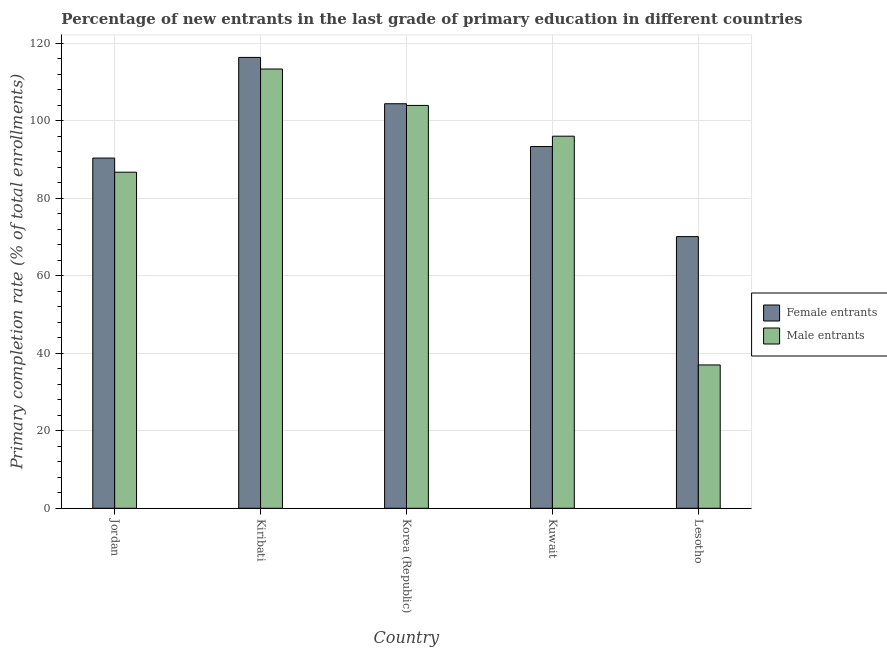How many different coloured bars are there?
Your answer should be compact. 2. How many groups of bars are there?
Provide a succinct answer. 5. Are the number of bars on each tick of the X-axis equal?
Give a very brief answer. Yes. What is the label of the 3rd group of bars from the left?
Your response must be concise. Korea (Republic). What is the primary completion rate of female entrants in Lesotho?
Your answer should be very brief. 70.12. Across all countries, what is the maximum primary completion rate of male entrants?
Give a very brief answer. 113.37. Across all countries, what is the minimum primary completion rate of female entrants?
Provide a short and direct response. 70.12. In which country was the primary completion rate of male entrants maximum?
Your answer should be compact. Kiribati. In which country was the primary completion rate of male entrants minimum?
Your answer should be compact. Lesotho. What is the total primary completion rate of male entrants in the graph?
Offer a very short reply. 437.12. What is the difference between the primary completion rate of female entrants in Kiribati and that in Korea (Republic)?
Ensure brevity in your answer.  11.96. What is the difference between the primary completion rate of female entrants in Kiribati and the primary completion rate of male entrants in Kuwait?
Keep it short and to the point. 20.33. What is the average primary completion rate of male entrants per country?
Offer a very short reply. 87.42. What is the difference between the primary completion rate of female entrants and primary completion rate of male entrants in Lesotho?
Offer a very short reply. 33.13. In how many countries, is the primary completion rate of male entrants greater than 96 %?
Give a very brief answer. 3. What is the ratio of the primary completion rate of male entrants in Jordan to that in Kuwait?
Provide a succinct answer. 0.9. Is the primary completion rate of male entrants in Kuwait less than that in Lesotho?
Your answer should be very brief. No. What is the difference between the highest and the second highest primary completion rate of female entrants?
Provide a short and direct response. 11.96. What is the difference between the highest and the lowest primary completion rate of female entrants?
Your answer should be very brief. 46.25. In how many countries, is the primary completion rate of female entrants greater than the average primary completion rate of female entrants taken over all countries?
Offer a terse response. 2. What does the 2nd bar from the left in Lesotho represents?
Your answer should be compact. Male entrants. What does the 1st bar from the right in Jordan represents?
Provide a short and direct response. Male entrants. Are all the bars in the graph horizontal?
Your answer should be very brief. No. What is the difference between two consecutive major ticks on the Y-axis?
Keep it short and to the point. 20. Are the values on the major ticks of Y-axis written in scientific E-notation?
Your response must be concise. No. Does the graph contain any zero values?
Offer a very short reply. No. How many legend labels are there?
Your answer should be very brief. 2. How are the legend labels stacked?
Provide a succinct answer. Vertical. What is the title of the graph?
Ensure brevity in your answer.  Percentage of new entrants in the last grade of primary education in different countries. Does "Electricity and heat production" appear as one of the legend labels in the graph?
Give a very brief answer. No. What is the label or title of the Y-axis?
Offer a terse response. Primary completion rate (% of total enrollments). What is the Primary completion rate (% of total enrollments) of Female entrants in Jordan?
Offer a very short reply. 90.39. What is the Primary completion rate (% of total enrollments) in Male entrants in Jordan?
Your answer should be very brief. 86.74. What is the Primary completion rate (% of total enrollments) in Female entrants in Kiribati?
Provide a succinct answer. 116.37. What is the Primary completion rate (% of total enrollments) of Male entrants in Kiribati?
Offer a very short reply. 113.37. What is the Primary completion rate (% of total enrollments) in Female entrants in Korea (Republic)?
Your answer should be compact. 104.41. What is the Primary completion rate (% of total enrollments) in Male entrants in Korea (Republic)?
Your answer should be compact. 103.97. What is the Primary completion rate (% of total enrollments) in Female entrants in Kuwait?
Your response must be concise. 93.36. What is the Primary completion rate (% of total enrollments) in Male entrants in Kuwait?
Offer a terse response. 96.04. What is the Primary completion rate (% of total enrollments) of Female entrants in Lesotho?
Provide a succinct answer. 70.12. What is the Primary completion rate (% of total enrollments) in Male entrants in Lesotho?
Make the answer very short. 36.99. Across all countries, what is the maximum Primary completion rate (% of total enrollments) of Female entrants?
Your response must be concise. 116.37. Across all countries, what is the maximum Primary completion rate (% of total enrollments) of Male entrants?
Your answer should be very brief. 113.37. Across all countries, what is the minimum Primary completion rate (% of total enrollments) of Female entrants?
Give a very brief answer. 70.12. Across all countries, what is the minimum Primary completion rate (% of total enrollments) of Male entrants?
Ensure brevity in your answer.  36.99. What is the total Primary completion rate (% of total enrollments) in Female entrants in the graph?
Offer a very short reply. 474.65. What is the total Primary completion rate (% of total enrollments) of Male entrants in the graph?
Make the answer very short. 437.12. What is the difference between the Primary completion rate (% of total enrollments) of Female entrants in Jordan and that in Kiribati?
Give a very brief answer. -25.98. What is the difference between the Primary completion rate (% of total enrollments) of Male entrants in Jordan and that in Kiribati?
Offer a very short reply. -26.63. What is the difference between the Primary completion rate (% of total enrollments) in Female entrants in Jordan and that in Korea (Republic)?
Make the answer very short. -14.02. What is the difference between the Primary completion rate (% of total enrollments) in Male entrants in Jordan and that in Korea (Republic)?
Provide a short and direct response. -17.23. What is the difference between the Primary completion rate (% of total enrollments) in Female entrants in Jordan and that in Kuwait?
Offer a very short reply. -2.97. What is the difference between the Primary completion rate (% of total enrollments) of Male entrants in Jordan and that in Kuwait?
Ensure brevity in your answer.  -9.29. What is the difference between the Primary completion rate (% of total enrollments) in Female entrants in Jordan and that in Lesotho?
Make the answer very short. 20.27. What is the difference between the Primary completion rate (% of total enrollments) of Male entrants in Jordan and that in Lesotho?
Provide a succinct answer. 49.75. What is the difference between the Primary completion rate (% of total enrollments) in Female entrants in Kiribati and that in Korea (Republic)?
Give a very brief answer. 11.96. What is the difference between the Primary completion rate (% of total enrollments) of Male entrants in Kiribati and that in Korea (Republic)?
Offer a terse response. 9.4. What is the difference between the Primary completion rate (% of total enrollments) of Female entrants in Kiribati and that in Kuwait?
Provide a short and direct response. 23. What is the difference between the Primary completion rate (% of total enrollments) of Male entrants in Kiribati and that in Kuwait?
Your answer should be very brief. 17.34. What is the difference between the Primary completion rate (% of total enrollments) of Female entrants in Kiribati and that in Lesotho?
Provide a short and direct response. 46.25. What is the difference between the Primary completion rate (% of total enrollments) in Male entrants in Kiribati and that in Lesotho?
Give a very brief answer. 76.38. What is the difference between the Primary completion rate (% of total enrollments) of Female entrants in Korea (Republic) and that in Kuwait?
Give a very brief answer. 11.05. What is the difference between the Primary completion rate (% of total enrollments) in Male entrants in Korea (Republic) and that in Kuwait?
Ensure brevity in your answer.  7.94. What is the difference between the Primary completion rate (% of total enrollments) of Female entrants in Korea (Republic) and that in Lesotho?
Make the answer very short. 34.29. What is the difference between the Primary completion rate (% of total enrollments) in Male entrants in Korea (Republic) and that in Lesotho?
Ensure brevity in your answer.  66.98. What is the difference between the Primary completion rate (% of total enrollments) in Female entrants in Kuwait and that in Lesotho?
Your response must be concise. 23.25. What is the difference between the Primary completion rate (% of total enrollments) of Male entrants in Kuwait and that in Lesotho?
Make the answer very short. 59.05. What is the difference between the Primary completion rate (% of total enrollments) in Female entrants in Jordan and the Primary completion rate (% of total enrollments) in Male entrants in Kiribati?
Make the answer very short. -22.98. What is the difference between the Primary completion rate (% of total enrollments) of Female entrants in Jordan and the Primary completion rate (% of total enrollments) of Male entrants in Korea (Republic)?
Provide a succinct answer. -13.58. What is the difference between the Primary completion rate (% of total enrollments) of Female entrants in Jordan and the Primary completion rate (% of total enrollments) of Male entrants in Kuwait?
Provide a short and direct response. -5.65. What is the difference between the Primary completion rate (% of total enrollments) of Female entrants in Jordan and the Primary completion rate (% of total enrollments) of Male entrants in Lesotho?
Your answer should be compact. 53.4. What is the difference between the Primary completion rate (% of total enrollments) of Female entrants in Kiribati and the Primary completion rate (% of total enrollments) of Male entrants in Korea (Republic)?
Offer a terse response. 12.39. What is the difference between the Primary completion rate (% of total enrollments) in Female entrants in Kiribati and the Primary completion rate (% of total enrollments) in Male entrants in Kuwait?
Your answer should be very brief. 20.33. What is the difference between the Primary completion rate (% of total enrollments) in Female entrants in Kiribati and the Primary completion rate (% of total enrollments) in Male entrants in Lesotho?
Offer a very short reply. 79.37. What is the difference between the Primary completion rate (% of total enrollments) in Female entrants in Korea (Republic) and the Primary completion rate (% of total enrollments) in Male entrants in Kuwait?
Ensure brevity in your answer.  8.37. What is the difference between the Primary completion rate (% of total enrollments) in Female entrants in Korea (Republic) and the Primary completion rate (% of total enrollments) in Male entrants in Lesotho?
Give a very brief answer. 67.42. What is the difference between the Primary completion rate (% of total enrollments) in Female entrants in Kuwait and the Primary completion rate (% of total enrollments) in Male entrants in Lesotho?
Offer a terse response. 56.37. What is the average Primary completion rate (% of total enrollments) in Female entrants per country?
Give a very brief answer. 94.93. What is the average Primary completion rate (% of total enrollments) of Male entrants per country?
Your answer should be compact. 87.42. What is the difference between the Primary completion rate (% of total enrollments) in Female entrants and Primary completion rate (% of total enrollments) in Male entrants in Jordan?
Provide a short and direct response. 3.65. What is the difference between the Primary completion rate (% of total enrollments) of Female entrants and Primary completion rate (% of total enrollments) of Male entrants in Kiribati?
Offer a very short reply. 2.99. What is the difference between the Primary completion rate (% of total enrollments) in Female entrants and Primary completion rate (% of total enrollments) in Male entrants in Korea (Republic)?
Your answer should be very brief. 0.44. What is the difference between the Primary completion rate (% of total enrollments) in Female entrants and Primary completion rate (% of total enrollments) in Male entrants in Kuwait?
Offer a very short reply. -2.67. What is the difference between the Primary completion rate (% of total enrollments) of Female entrants and Primary completion rate (% of total enrollments) of Male entrants in Lesotho?
Your answer should be compact. 33.13. What is the ratio of the Primary completion rate (% of total enrollments) in Female entrants in Jordan to that in Kiribati?
Give a very brief answer. 0.78. What is the ratio of the Primary completion rate (% of total enrollments) in Male entrants in Jordan to that in Kiribati?
Ensure brevity in your answer.  0.77. What is the ratio of the Primary completion rate (% of total enrollments) of Female entrants in Jordan to that in Korea (Republic)?
Offer a terse response. 0.87. What is the ratio of the Primary completion rate (% of total enrollments) in Male entrants in Jordan to that in Korea (Republic)?
Provide a short and direct response. 0.83. What is the ratio of the Primary completion rate (% of total enrollments) of Female entrants in Jordan to that in Kuwait?
Provide a short and direct response. 0.97. What is the ratio of the Primary completion rate (% of total enrollments) of Male entrants in Jordan to that in Kuwait?
Provide a succinct answer. 0.9. What is the ratio of the Primary completion rate (% of total enrollments) of Female entrants in Jordan to that in Lesotho?
Your answer should be compact. 1.29. What is the ratio of the Primary completion rate (% of total enrollments) of Male entrants in Jordan to that in Lesotho?
Give a very brief answer. 2.34. What is the ratio of the Primary completion rate (% of total enrollments) of Female entrants in Kiribati to that in Korea (Republic)?
Ensure brevity in your answer.  1.11. What is the ratio of the Primary completion rate (% of total enrollments) in Male entrants in Kiribati to that in Korea (Republic)?
Make the answer very short. 1.09. What is the ratio of the Primary completion rate (% of total enrollments) of Female entrants in Kiribati to that in Kuwait?
Offer a terse response. 1.25. What is the ratio of the Primary completion rate (% of total enrollments) in Male entrants in Kiribati to that in Kuwait?
Offer a terse response. 1.18. What is the ratio of the Primary completion rate (% of total enrollments) in Female entrants in Kiribati to that in Lesotho?
Ensure brevity in your answer.  1.66. What is the ratio of the Primary completion rate (% of total enrollments) in Male entrants in Kiribati to that in Lesotho?
Ensure brevity in your answer.  3.06. What is the ratio of the Primary completion rate (% of total enrollments) of Female entrants in Korea (Republic) to that in Kuwait?
Provide a short and direct response. 1.12. What is the ratio of the Primary completion rate (% of total enrollments) in Male entrants in Korea (Republic) to that in Kuwait?
Offer a very short reply. 1.08. What is the ratio of the Primary completion rate (% of total enrollments) in Female entrants in Korea (Republic) to that in Lesotho?
Offer a terse response. 1.49. What is the ratio of the Primary completion rate (% of total enrollments) in Male entrants in Korea (Republic) to that in Lesotho?
Make the answer very short. 2.81. What is the ratio of the Primary completion rate (% of total enrollments) in Female entrants in Kuwait to that in Lesotho?
Your answer should be very brief. 1.33. What is the ratio of the Primary completion rate (% of total enrollments) of Male entrants in Kuwait to that in Lesotho?
Provide a short and direct response. 2.6. What is the difference between the highest and the second highest Primary completion rate (% of total enrollments) of Female entrants?
Your response must be concise. 11.96. What is the difference between the highest and the second highest Primary completion rate (% of total enrollments) in Male entrants?
Your answer should be compact. 9.4. What is the difference between the highest and the lowest Primary completion rate (% of total enrollments) of Female entrants?
Your answer should be very brief. 46.25. What is the difference between the highest and the lowest Primary completion rate (% of total enrollments) in Male entrants?
Your answer should be compact. 76.38. 